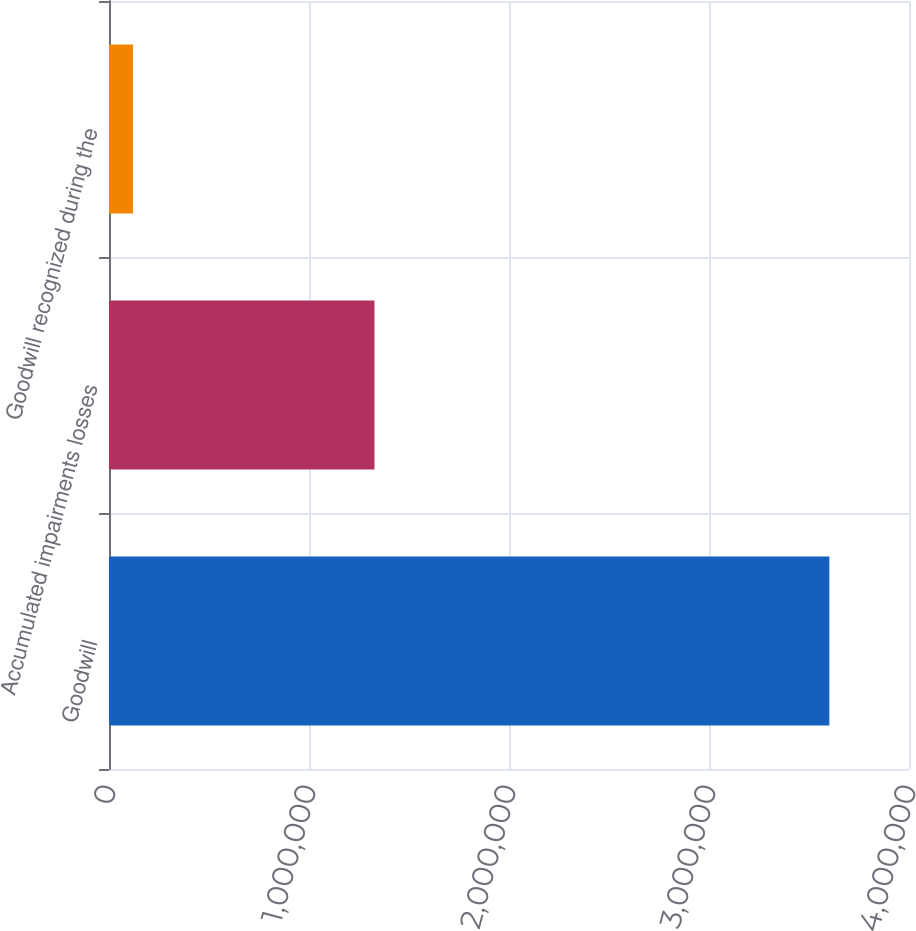Convert chart to OTSL. <chart><loc_0><loc_0><loc_500><loc_500><bar_chart><fcel>Goodwill<fcel>Accumulated impairments losses<fcel>Goodwill recognized during the<nl><fcel>3.60185e+06<fcel>1.32742e+06<fcel>119738<nl></chart> 